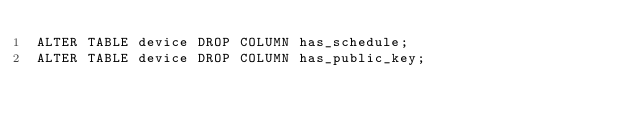<code> <loc_0><loc_0><loc_500><loc_500><_SQL_>ALTER TABLE device DROP COLUMN has_schedule;
ALTER TABLE device DROP COLUMN has_public_key;</code> 